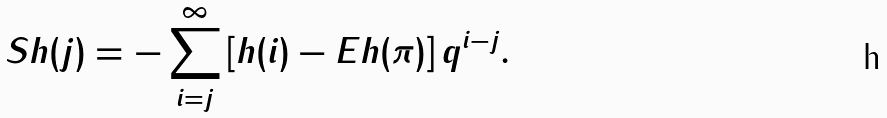Convert formula to latex. <formula><loc_0><loc_0><loc_500><loc_500>S h ( j ) = - \sum _ { i = j } ^ { \infty } \left [ h ( i ) - E h ( \pi ) \right ] q ^ { i - j } .</formula> 